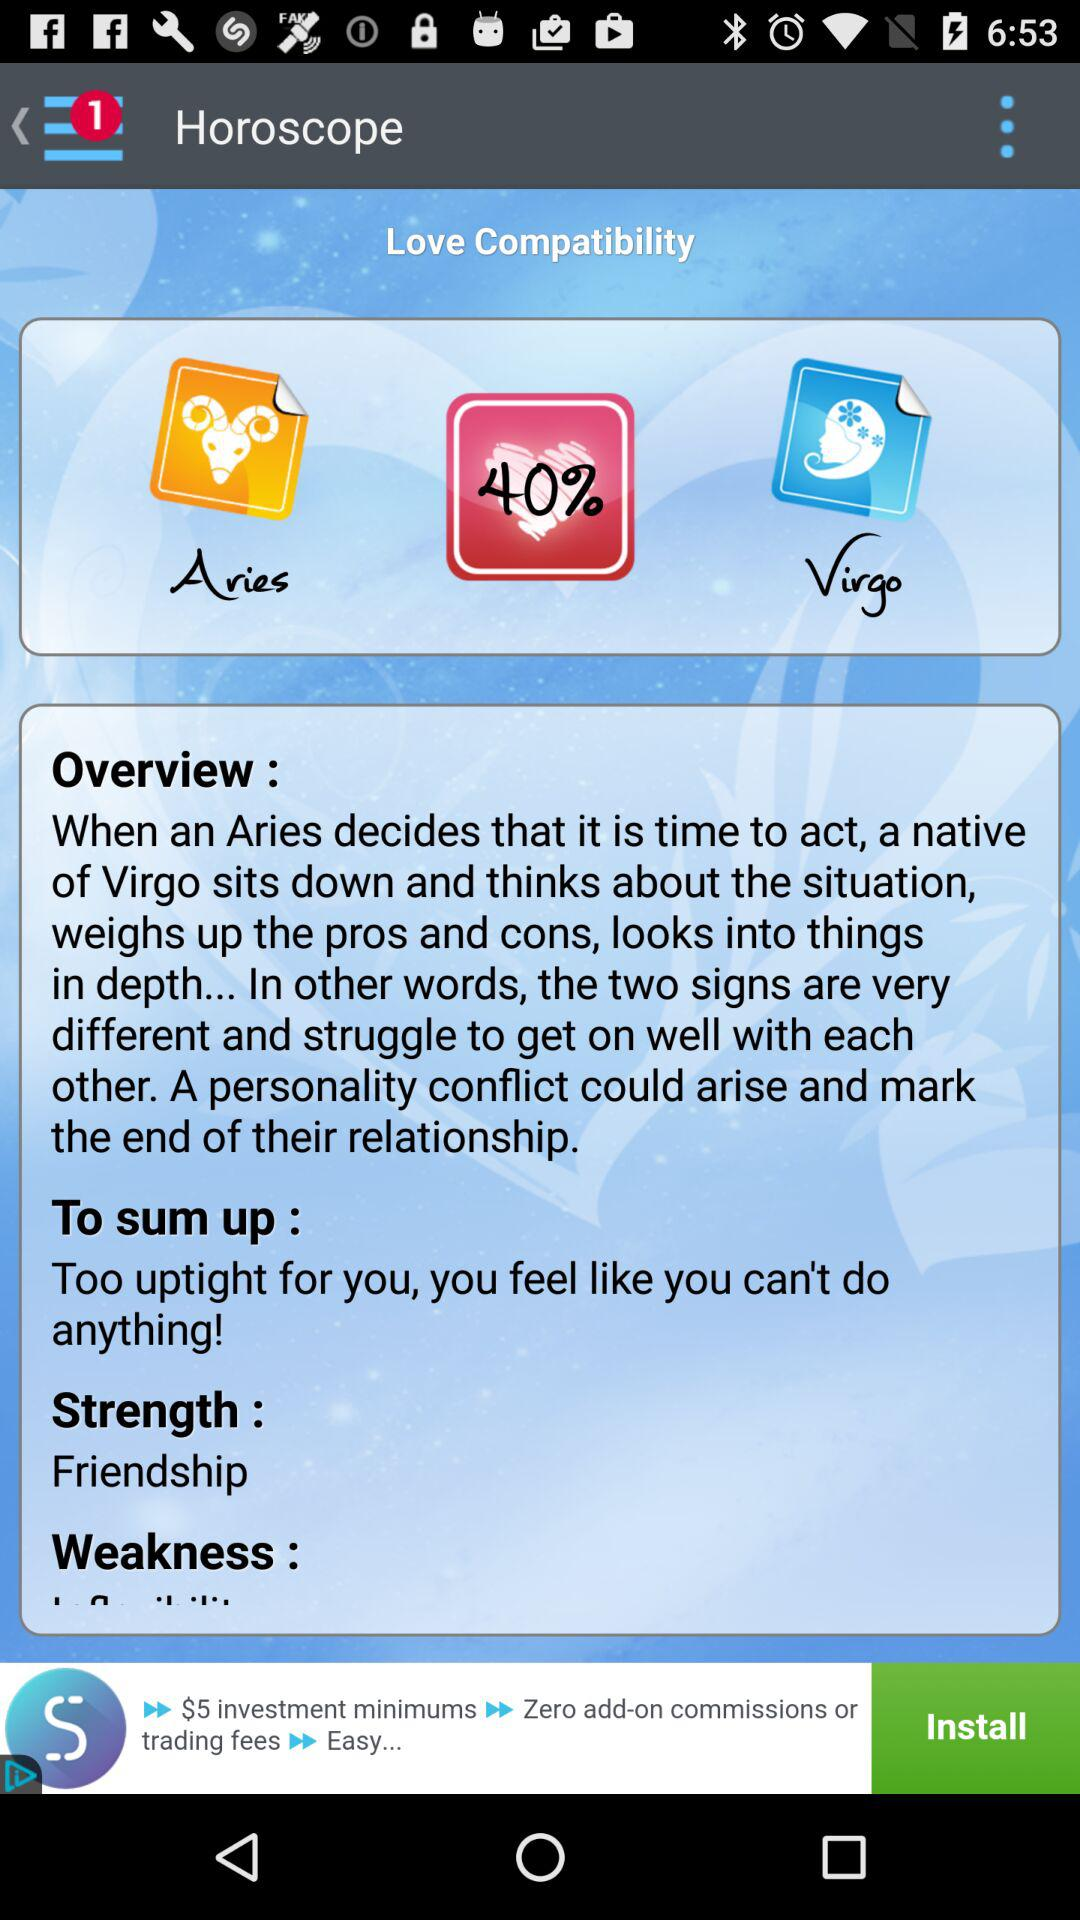What is the percentage of love compatibility? The percentage is 40. 